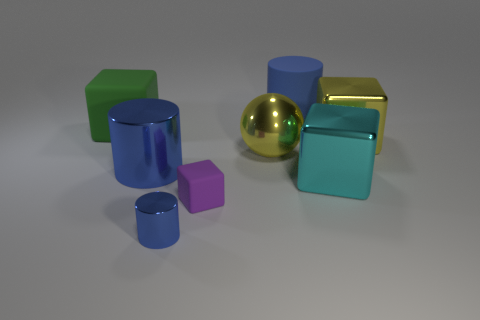What can you infer about the surface these objects are resting on? The surface appears to be smooth and matte, allowing for subtle reflections, particularly noticeable on the metallic objects. It's likely a solid, non-textured material without any distinctive features, which provides a plain backdrop that emphasizes the objects themselves. 